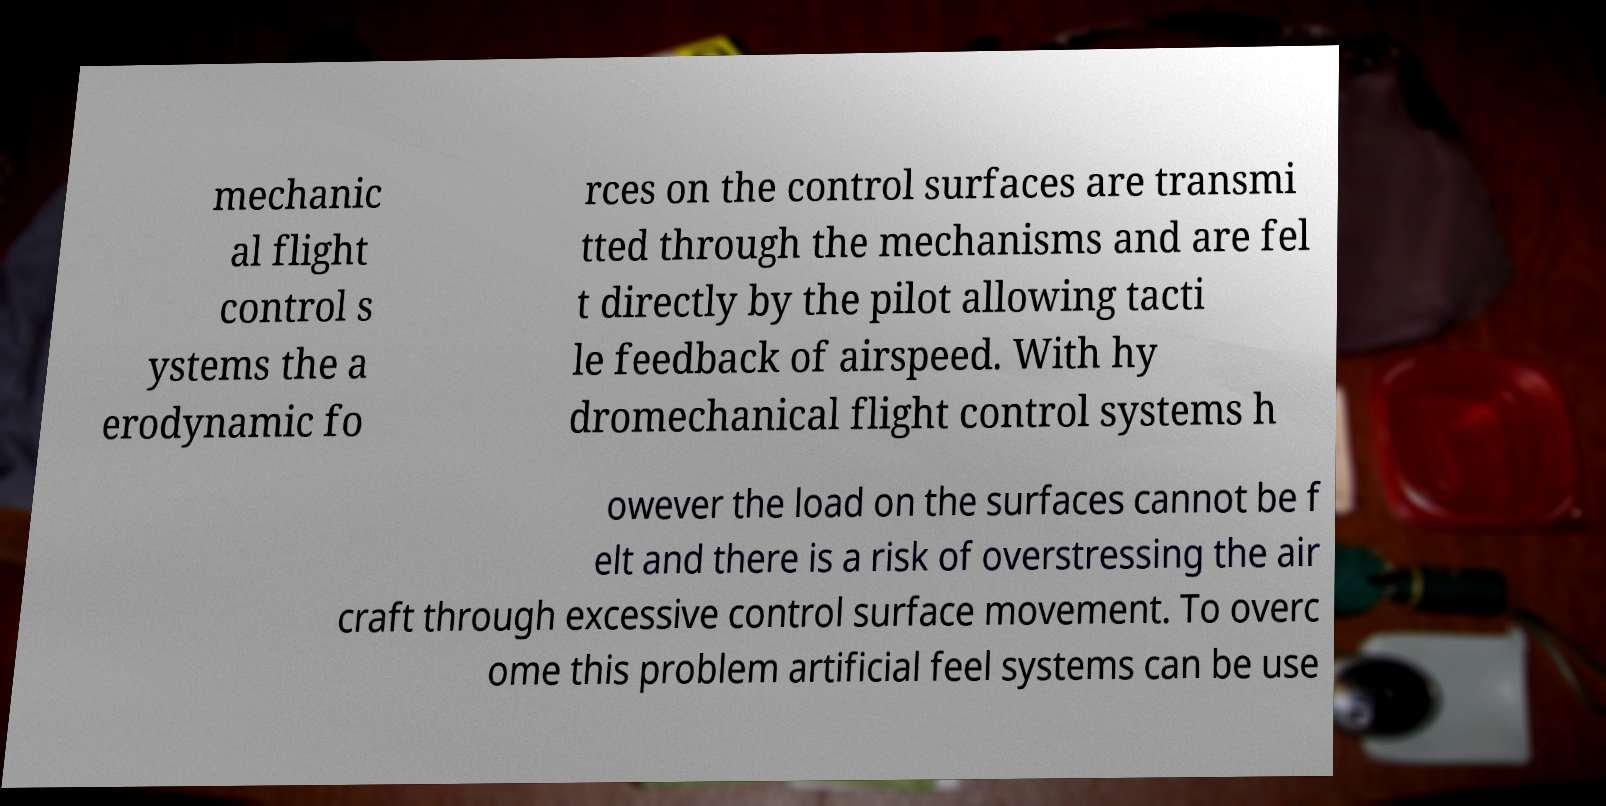Please identify and transcribe the text found in this image. mechanic al flight control s ystems the a erodynamic fo rces on the control surfaces are transmi tted through the mechanisms and are fel t directly by the pilot allowing tacti le feedback of airspeed. With hy dromechanical flight control systems h owever the load on the surfaces cannot be f elt and there is a risk of overstressing the air craft through excessive control surface movement. To overc ome this problem artificial feel systems can be use 